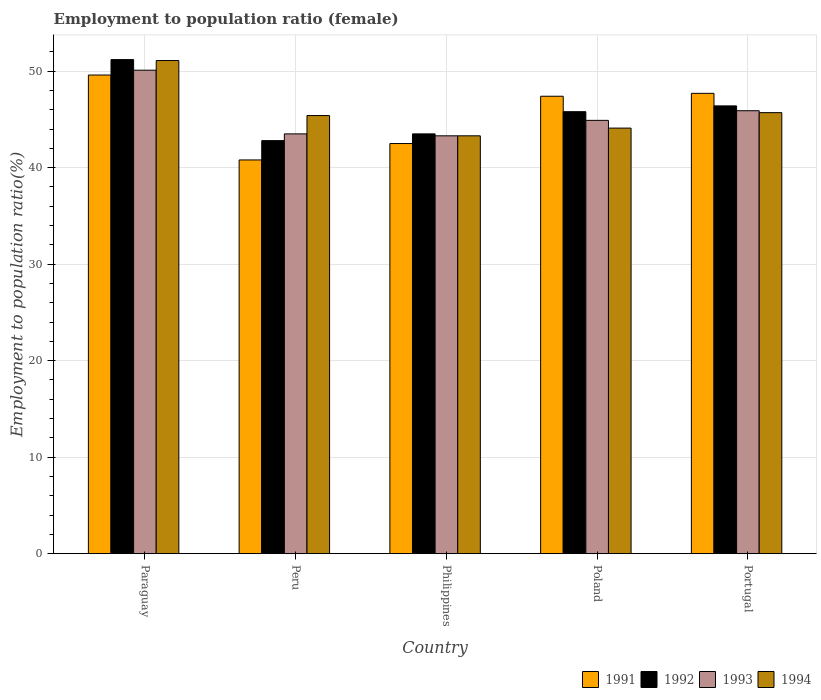How many different coloured bars are there?
Provide a short and direct response. 4. How many groups of bars are there?
Your answer should be very brief. 5. Are the number of bars per tick equal to the number of legend labels?
Provide a succinct answer. Yes. How many bars are there on the 1st tick from the left?
Give a very brief answer. 4. What is the label of the 1st group of bars from the left?
Offer a very short reply. Paraguay. In how many cases, is the number of bars for a given country not equal to the number of legend labels?
Your answer should be compact. 0. What is the employment to population ratio in 1992 in Portugal?
Keep it short and to the point. 46.4. Across all countries, what is the maximum employment to population ratio in 1993?
Your answer should be very brief. 50.1. Across all countries, what is the minimum employment to population ratio in 1993?
Your answer should be very brief. 43.3. In which country was the employment to population ratio in 1994 maximum?
Make the answer very short. Paraguay. What is the total employment to population ratio in 1992 in the graph?
Keep it short and to the point. 229.7. What is the difference between the employment to population ratio in 1993 in Philippines and that in Portugal?
Keep it short and to the point. -2.6. What is the difference between the employment to population ratio in 1992 in Paraguay and the employment to population ratio in 1993 in Peru?
Offer a terse response. 7.7. What is the average employment to population ratio in 1991 per country?
Ensure brevity in your answer.  45.6. What is the difference between the employment to population ratio of/in 1994 and employment to population ratio of/in 1991 in Philippines?
Your answer should be very brief. 0.8. What is the ratio of the employment to population ratio in 1991 in Poland to that in Portugal?
Your answer should be very brief. 0.99. Is the difference between the employment to population ratio in 1994 in Peru and Poland greater than the difference between the employment to population ratio in 1991 in Peru and Poland?
Provide a succinct answer. Yes. What is the difference between the highest and the second highest employment to population ratio in 1994?
Keep it short and to the point. -5.7. What is the difference between the highest and the lowest employment to population ratio in 1994?
Ensure brevity in your answer.  7.8. Is the sum of the employment to population ratio in 1991 in Peru and Poland greater than the maximum employment to population ratio in 1993 across all countries?
Offer a terse response. Yes. Is it the case that in every country, the sum of the employment to population ratio in 1992 and employment to population ratio in 1994 is greater than the sum of employment to population ratio in 1991 and employment to population ratio in 1993?
Offer a very short reply. No. What does the 4th bar from the right in Poland represents?
Your response must be concise. 1991. Are all the bars in the graph horizontal?
Provide a short and direct response. No. How many countries are there in the graph?
Your response must be concise. 5. What is the difference between two consecutive major ticks on the Y-axis?
Offer a very short reply. 10. What is the title of the graph?
Offer a very short reply. Employment to population ratio (female). Does "1969" appear as one of the legend labels in the graph?
Offer a very short reply. No. What is the label or title of the X-axis?
Ensure brevity in your answer.  Country. What is the label or title of the Y-axis?
Make the answer very short. Employment to population ratio(%). What is the Employment to population ratio(%) of 1991 in Paraguay?
Your response must be concise. 49.6. What is the Employment to population ratio(%) in 1992 in Paraguay?
Make the answer very short. 51.2. What is the Employment to population ratio(%) of 1993 in Paraguay?
Ensure brevity in your answer.  50.1. What is the Employment to population ratio(%) in 1994 in Paraguay?
Your response must be concise. 51.1. What is the Employment to population ratio(%) in 1991 in Peru?
Make the answer very short. 40.8. What is the Employment to population ratio(%) in 1992 in Peru?
Provide a short and direct response. 42.8. What is the Employment to population ratio(%) in 1993 in Peru?
Offer a terse response. 43.5. What is the Employment to population ratio(%) in 1994 in Peru?
Your answer should be very brief. 45.4. What is the Employment to population ratio(%) in 1991 in Philippines?
Your answer should be very brief. 42.5. What is the Employment to population ratio(%) in 1992 in Philippines?
Your answer should be compact. 43.5. What is the Employment to population ratio(%) of 1993 in Philippines?
Your response must be concise. 43.3. What is the Employment to population ratio(%) of 1994 in Philippines?
Your answer should be compact. 43.3. What is the Employment to population ratio(%) in 1991 in Poland?
Your answer should be compact. 47.4. What is the Employment to population ratio(%) of 1992 in Poland?
Keep it short and to the point. 45.8. What is the Employment to population ratio(%) in 1993 in Poland?
Offer a very short reply. 44.9. What is the Employment to population ratio(%) in 1994 in Poland?
Your answer should be very brief. 44.1. What is the Employment to population ratio(%) in 1991 in Portugal?
Provide a succinct answer. 47.7. What is the Employment to population ratio(%) of 1992 in Portugal?
Keep it short and to the point. 46.4. What is the Employment to population ratio(%) of 1993 in Portugal?
Offer a very short reply. 45.9. What is the Employment to population ratio(%) in 1994 in Portugal?
Keep it short and to the point. 45.7. Across all countries, what is the maximum Employment to population ratio(%) in 1991?
Provide a short and direct response. 49.6. Across all countries, what is the maximum Employment to population ratio(%) of 1992?
Ensure brevity in your answer.  51.2. Across all countries, what is the maximum Employment to population ratio(%) in 1993?
Keep it short and to the point. 50.1. Across all countries, what is the maximum Employment to population ratio(%) in 1994?
Your response must be concise. 51.1. Across all countries, what is the minimum Employment to population ratio(%) of 1991?
Your answer should be compact. 40.8. Across all countries, what is the minimum Employment to population ratio(%) in 1992?
Provide a succinct answer. 42.8. Across all countries, what is the minimum Employment to population ratio(%) in 1993?
Provide a short and direct response. 43.3. Across all countries, what is the minimum Employment to population ratio(%) in 1994?
Your response must be concise. 43.3. What is the total Employment to population ratio(%) in 1991 in the graph?
Ensure brevity in your answer.  228. What is the total Employment to population ratio(%) of 1992 in the graph?
Ensure brevity in your answer.  229.7. What is the total Employment to population ratio(%) of 1993 in the graph?
Offer a terse response. 227.7. What is the total Employment to population ratio(%) in 1994 in the graph?
Keep it short and to the point. 229.6. What is the difference between the Employment to population ratio(%) in 1991 in Paraguay and that in Peru?
Keep it short and to the point. 8.8. What is the difference between the Employment to population ratio(%) in 1993 in Paraguay and that in Peru?
Your answer should be compact. 6.6. What is the difference between the Employment to population ratio(%) in 1994 in Paraguay and that in Peru?
Your response must be concise. 5.7. What is the difference between the Employment to population ratio(%) in 1991 in Paraguay and that in Philippines?
Your answer should be compact. 7.1. What is the difference between the Employment to population ratio(%) of 1993 in Paraguay and that in Philippines?
Give a very brief answer. 6.8. What is the difference between the Employment to population ratio(%) in 1994 in Paraguay and that in Philippines?
Give a very brief answer. 7.8. What is the difference between the Employment to population ratio(%) in 1991 in Paraguay and that in Poland?
Your answer should be compact. 2.2. What is the difference between the Employment to population ratio(%) in 1993 in Paraguay and that in Poland?
Keep it short and to the point. 5.2. What is the difference between the Employment to population ratio(%) in 1992 in Paraguay and that in Portugal?
Give a very brief answer. 4.8. What is the difference between the Employment to population ratio(%) in 1994 in Paraguay and that in Portugal?
Your answer should be compact. 5.4. What is the difference between the Employment to population ratio(%) of 1993 in Peru and that in Philippines?
Make the answer very short. 0.2. What is the difference between the Employment to population ratio(%) of 1994 in Peru and that in Philippines?
Ensure brevity in your answer.  2.1. What is the difference between the Employment to population ratio(%) of 1991 in Peru and that in Poland?
Your response must be concise. -6.6. What is the difference between the Employment to population ratio(%) in 1994 in Peru and that in Poland?
Make the answer very short. 1.3. What is the difference between the Employment to population ratio(%) in 1991 in Peru and that in Portugal?
Keep it short and to the point. -6.9. What is the difference between the Employment to population ratio(%) in 1994 in Peru and that in Portugal?
Offer a very short reply. -0.3. What is the difference between the Employment to population ratio(%) of 1992 in Philippines and that in Poland?
Keep it short and to the point. -2.3. What is the difference between the Employment to population ratio(%) in 1993 in Philippines and that in Poland?
Offer a very short reply. -1.6. What is the difference between the Employment to population ratio(%) in 1994 in Philippines and that in Poland?
Make the answer very short. -0.8. What is the difference between the Employment to population ratio(%) of 1993 in Philippines and that in Portugal?
Your response must be concise. -2.6. What is the difference between the Employment to population ratio(%) in 1994 in Philippines and that in Portugal?
Offer a terse response. -2.4. What is the difference between the Employment to population ratio(%) in 1991 in Poland and that in Portugal?
Make the answer very short. -0.3. What is the difference between the Employment to population ratio(%) of 1993 in Poland and that in Portugal?
Make the answer very short. -1. What is the difference between the Employment to population ratio(%) in 1994 in Poland and that in Portugal?
Provide a succinct answer. -1.6. What is the difference between the Employment to population ratio(%) in 1991 in Paraguay and the Employment to population ratio(%) in 1993 in Peru?
Your answer should be compact. 6.1. What is the difference between the Employment to population ratio(%) of 1992 in Paraguay and the Employment to population ratio(%) of 1993 in Peru?
Ensure brevity in your answer.  7.7. What is the difference between the Employment to population ratio(%) in 1991 in Paraguay and the Employment to population ratio(%) in 1993 in Philippines?
Your answer should be very brief. 6.3. What is the difference between the Employment to population ratio(%) of 1992 in Paraguay and the Employment to population ratio(%) of 1993 in Philippines?
Make the answer very short. 7.9. What is the difference between the Employment to population ratio(%) in 1991 in Paraguay and the Employment to population ratio(%) in 1992 in Poland?
Your response must be concise. 3.8. What is the difference between the Employment to population ratio(%) of 1991 in Paraguay and the Employment to population ratio(%) of 1993 in Poland?
Keep it short and to the point. 4.7. What is the difference between the Employment to population ratio(%) in 1991 in Paraguay and the Employment to population ratio(%) in 1994 in Poland?
Give a very brief answer. 5.5. What is the difference between the Employment to population ratio(%) in 1992 in Paraguay and the Employment to population ratio(%) in 1993 in Poland?
Offer a very short reply. 6.3. What is the difference between the Employment to population ratio(%) of 1992 in Paraguay and the Employment to population ratio(%) of 1994 in Poland?
Keep it short and to the point. 7.1. What is the difference between the Employment to population ratio(%) in 1991 in Paraguay and the Employment to population ratio(%) in 1993 in Portugal?
Ensure brevity in your answer.  3.7. What is the difference between the Employment to population ratio(%) in 1992 in Paraguay and the Employment to population ratio(%) in 1993 in Portugal?
Your answer should be compact. 5.3. What is the difference between the Employment to population ratio(%) of 1992 in Paraguay and the Employment to population ratio(%) of 1994 in Portugal?
Your response must be concise. 5.5. What is the difference between the Employment to population ratio(%) of 1993 in Paraguay and the Employment to population ratio(%) of 1994 in Portugal?
Make the answer very short. 4.4. What is the difference between the Employment to population ratio(%) in 1991 in Peru and the Employment to population ratio(%) in 1993 in Philippines?
Offer a terse response. -2.5. What is the difference between the Employment to population ratio(%) in 1992 in Peru and the Employment to population ratio(%) in 1993 in Philippines?
Keep it short and to the point. -0.5. What is the difference between the Employment to population ratio(%) of 1992 in Peru and the Employment to population ratio(%) of 1994 in Philippines?
Ensure brevity in your answer.  -0.5. What is the difference between the Employment to population ratio(%) in 1993 in Peru and the Employment to population ratio(%) in 1994 in Philippines?
Your answer should be very brief. 0.2. What is the difference between the Employment to population ratio(%) in 1991 in Peru and the Employment to population ratio(%) in 1993 in Poland?
Your answer should be very brief. -4.1. What is the difference between the Employment to population ratio(%) in 1992 in Peru and the Employment to population ratio(%) in 1993 in Poland?
Provide a succinct answer. -2.1. What is the difference between the Employment to population ratio(%) of 1992 in Peru and the Employment to population ratio(%) of 1994 in Poland?
Keep it short and to the point. -1.3. What is the difference between the Employment to population ratio(%) in 1991 in Peru and the Employment to population ratio(%) in 1992 in Portugal?
Your response must be concise. -5.6. What is the difference between the Employment to population ratio(%) of 1991 in Peru and the Employment to population ratio(%) of 1993 in Portugal?
Give a very brief answer. -5.1. What is the difference between the Employment to population ratio(%) of 1991 in Peru and the Employment to population ratio(%) of 1994 in Portugal?
Your answer should be very brief. -4.9. What is the difference between the Employment to population ratio(%) of 1992 in Peru and the Employment to population ratio(%) of 1993 in Portugal?
Keep it short and to the point. -3.1. What is the difference between the Employment to population ratio(%) in 1992 in Peru and the Employment to population ratio(%) in 1994 in Portugal?
Your answer should be very brief. -2.9. What is the difference between the Employment to population ratio(%) of 1993 in Peru and the Employment to population ratio(%) of 1994 in Portugal?
Ensure brevity in your answer.  -2.2. What is the difference between the Employment to population ratio(%) of 1991 in Philippines and the Employment to population ratio(%) of 1993 in Poland?
Your response must be concise. -2.4. What is the difference between the Employment to population ratio(%) in 1992 in Philippines and the Employment to population ratio(%) in 1994 in Poland?
Keep it short and to the point. -0.6. What is the difference between the Employment to population ratio(%) of 1993 in Philippines and the Employment to population ratio(%) of 1994 in Poland?
Your answer should be very brief. -0.8. What is the difference between the Employment to population ratio(%) of 1991 in Philippines and the Employment to population ratio(%) of 1993 in Portugal?
Give a very brief answer. -3.4. What is the difference between the Employment to population ratio(%) in 1991 in Philippines and the Employment to population ratio(%) in 1994 in Portugal?
Your answer should be compact. -3.2. What is the difference between the Employment to population ratio(%) in 1991 in Poland and the Employment to population ratio(%) in 1994 in Portugal?
Provide a short and direct response. 1.7. What is the difference between the Employment to population ratio(%) of 1993 in Poland and the Employment to population ratio(%) of 1994 in Portugal?
Ensure brevity in your answer.  -0.8. What is the average Employment to population ratio(%) of 1991 per country?
Your answer should be very brief. 45.6. What is the average Employment to population ratio(%) in 1992 per country?
Ensure brevity in your answer.  45.94. What is the average Employment to population ratio(%) of 1993 per country?
Provide a short and direct response. 45.54. What is the average Employment to population ratio(%) in 1994 per country?
Ensure brevity in your answer.  45.92. What is the difference between the Employment to population ratio(%) of 1991 and Employment to population ratio(%) of 1993 in Paraguay?
Your answer should be very brief. -0.5. What is the difference between the Employment to population ratio(%) of 1991 and Employment to population ratio(%) of 1994 in Paraguay?
Your answer should be compact. -1.5. What is the difference between the Employment to population ratio(%) of 1991 and Employment to population ratio(%) of 1993 in Philippines?
Offer a very short reply. -0.8. What is the difference between the Employment to population ratio(%) in 1991 and Employment to population ratio(%) in 1994 in Philippines?
Your answer should be very brief. -0.8. What is the difference between the Employment to population ratio(%) in 1992 and Employment to population ratio(%) in 1993 in Philippines?
Offer a terse response. 0.2. What is the difference between the Employment to population ratio(%) of 1992 and Employment to population ratio(%) of 1994 in Philippines?
Your response must be concise. 0.2. What is the difference between the Employment to population ratio(%) in 1993 and Employment to population ratio(%) in 1994 in Philippines?
Your response must be concise. 0. What is the difference between the Employment to population ratio(%) in 1991 and Employment to population ratio(%) in 1992 in Poland?
Make the answer very short. 1.6. What is the difference between the Employment to population ratio(%) in 1991 and Employment to population ratio(%) in 1993 in Poland?
Provide a short and direct response. 2.5. What is the difference between the Employment to population ratio(%) of 1992 and Employment to population ratio(%) of 1993 in Poland?
Your response must be concise. 0.9. What is the difference between the Employment to population ratio(%) of 1993 and Employment to population ratio(%) of 1994 in Poland?
Your answer should be very brief. 0.8. What is the difference between the Employment to population ratio(%) in 1991 and Employment to population ratio(%) in 1992 in Portugal?
Your response must be concise. 1.3. What is the difference between the Employment to population ratio(%) of 1992 and Employment to population ratio(%) of 1993 in Portugal?
Provide a short and direct response. 0.5. What is the difference between the Employment to population ratio(%) in 1992 and Employment to population ratio(%) in 1994 in Portugal?
Give a very brief answer. 0.7. What is the difference between the Employment to population ratio(%) of 1993 and Employment to population ratio(%) of 1994 in Portugal?
Provide a succinct answer. 0.2. What is the ratio of the Employment to population ratio(%) in 1991 in Paraguay to that in Peru?
Offer a very short reply. 1.22. What is the ratio of the Employment to population ratio(%) in 1992 in Paraguay to that in Peru?
Provide a succinct answer. 1.2. What is the ratio of the Employment to population ratio(%) in 1993 in Paraguay to that in Peru?
Provide a short and direct response. 1.15. What is the ratio of the Employment to population ratio(%) of 1994 in Paraguay to that in Peru?
Give a very brief answer. 1.13. What is the ratio of the Employment to population ratio(%) of 1991 in Paraguay to that in Philippines?
Ensure brevity in your answer.  1.17. What is the ratio of the Employment to population ratio(%) in 1992 in Paraguay to that in Philippines?
Your answer should be compact. 1.18. What is the ratio of the Employment to population ratio(%) of 1993 in Paraguay to that in Philippines?
Your response must be concise. 1.16. What is the ratio of the Employment to population ratio(%) of 1994 in Paraguay to that in Philippines?
Give a very brief answer. 1.18. What is the ratio of the Employment to population ratio(%) in 1991 in Paraguay to that in Poland?
Provide a short and direct response. 1.05. What is the ratio of the Employment to population ratio(%) of 1992 in Paraguay to that in Poland?
Your response must be concise. 1.12. What is the ratio of the Employment to population ratio(%) in 1993 in Paraguay to that in Poland?
Offer a very short reply. 1.12. What is the ratio of the Employment to population ratio(%) in 1994 in Paraguay to that in Poland?
Your answer should be compact. 1.16. What is the ratio of the Employment to population ratio(%) in 1991 in Paraguay to that in Portugal?
Make the answer very short. 1.04. What is the ratio of the Employment to population ratio(%) in 1992 in Paraguay to that in Portugal?
Make the answer very short. 1.1. What is the ratio of the Employment to population ratio(%) in 1993 in Paraguay to that in Portugal?
Give a very brief answer. 1.09. What is the ratio of the Employment to population ratio(%) of 1994 in Paraguay to that in Portugal?
Provide a succinct answer. 1.12. What is the ratio of the Employment to population ratio(%) in 1991 in Peru to that in Philippines?
Your answer should be very brief. 0.96. What is the ratio of the Employment to population ratio(%) of 1992 in Peru to that in Philippines?
Your answer should be very brief. 0.98. What is the ratio of the Employment to population ratio(%) in 1994 in Peru to that in Philippines?
Your answer should be very brief. 1.05. What is the ratio of the Employment to population ratio(%) in 1991 in Peru to that in Poland?
Offer a terse response. 0.86. What is the ratio of the Employment to population ratio(%) of 1992 in Peru to that in Poland?
Ensure brevity in your answer.  0.93. What is the ratio of the Employment to population ratio(%) of 1993 in Peru to that in Poland?
Provide a succinct answer. 0.97. What is the ratio of the Employment to population ratio(%) in 1994 in Peru to that in Poland?
Provide a succinct answer. 1.03. What is the ratio of the Employment to population ratio(%) of 1991 in Peru to that in Portugal?
Make the answer very short. 0.86. What is the ratio of the Employment to population ratio(%) of 1992 in Peru to that in Portugal?
Your response must be concise. 0.92. What is the ratio of the Employment to population ratio(%) in 1993 in Peru to that in Portugal?
Provide a succinct answer. 0.95. What is the ratio of the Employment to population ratio(%) in 1991 in Philippines to that in Poland?
Ensure brevity in your answer.  0.9. What is the ratio of the Employment to population ratio(%) in 1992 in Philippines to that in Poland?
Give a very brief answer. 0.95. What is the ratio of the Employment to population ratio(%) in 1993 in Philippines to that in Poland?
Your answer should be compact. 0.96. What is the ratio of the Employment to population ratio(%) of 1994 in Philippines to that in Poland?
Keep it short and to the point. 0.98. What is the ratio of the Employment to population ratio(%) in 1991 in Philippines to that in Portugal?
Your answer should be compact. 0.89. What is the ratio of the Employment to population ratio(%) in 1993 in Philippines to that in Portugal?
Offer a terse response. 0.94. What is the ratio of the Employment to population ratio(%) of 1994 in Philippines to that in Portugal?
Your answer should be very brief. 0.95. What is the ratio of the Employment to population ratio(%) of 1992 in Poland to that in Portugal?
Give a very brief answer. 0.99. What is the ratio of the Employment to population ratio(%) of 1993 in Poland to that in Portugal?
Provide a succinct answer. 0.98. What is the ratio of the Employment to population ratio(%) of 1994 in Poland to that in Portugal?
Your answer should be compact. 0.96. What is the difference between the highest and the second highest Employment to population ratio(%) of 1991?
Ensure brevity in your answer.  1.9. What is the difference between the highest and the second highest Employment to population ratio(%) of 1993?
Offer a terse response. 4.2. What is the difference between the highest and the lowest Employment to population ratio(%) of 1992?
Keep it short and to the point. 8.4. 